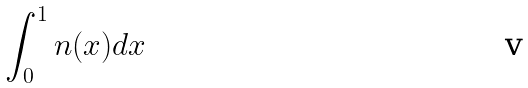<formula> <loc_0><loc_0><loc_500><loc_500>\int _ { 0 } ^ { 1 } n ( x ) d x</formula> 